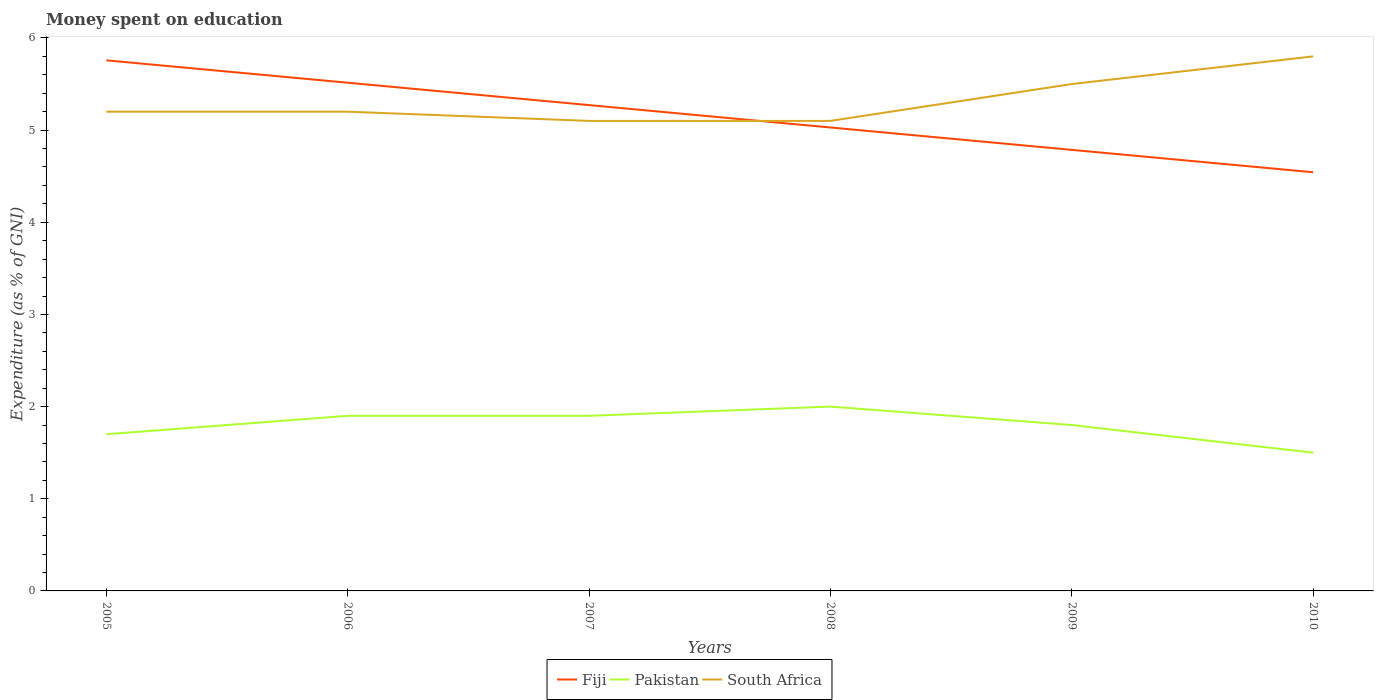Does the line corresponding to Pakistan intersect with the line corresponding to South Africa?
Your answer should be very brief. No. Is the number of lines equal to the number of legend labels?
Your response must be concise. Yes. What is the total amount of money spent on education in Pakistan in the graph?
Ensure brevity in your answer.  -0.2. What is the difference between the highest and the second highest amount of money spent on education in Pakistan?
Offer a terse response. 0.5. Is the amount of money spent on education in South Africa strictly greater than the amount of money spent on education in Pakistan over the years?
Offer a terse response. No. How many years are there in the graph?
Provide a short and direct response. 6. Are the values on the major ticks of Y-axis written in scientific E-notation?
Ensure brevity in your answer.  No. Does the graph contain any zero values?
Your response must be concise. No. Does the graph contain grids?
Your response must be concise. No. Where does the legend appear in the graph?
Your answer should be compact. Bottom center. How many legend labels are there?
Ensure brevity in your answer.  3. How are the legend labels stacked?
Keep it short and to the point. Horizontal. What is the title of the graph?
Make the answer very short. Money spent on education. What is the label or title of the Y-axis?
Keep it short and to the point. Expenditure (as % of GNI). What is the Expenditure (as % of GNI) in Fiji in 2005?
Provide a short and direct response. 5.76. What is the Expenditure (as % of GNI) of Fiji in 2006?
Ensure brevity in your answer.  5.51. What is the Expenditure (as % of GNI) of Pakistan in 2006?
Keep it short and to the point. 1.9. What is the Expenditure (as % of GNI) in Fiji in 2007?
Keep it short and to the point. 5.27. What is the Expenditure (as % of GNI) in Pakistan in 2007?
Your response must be concise. 1.9. What is the Expenditure (as % of GNI) in Fiji in 2008?
Offer a very short reply. 5.03. What is the Expenditure (as % of GNI) of Fiji in 2009?
Make the answer very short. 4.79. What is the Expenditure (as % of GNI) in Pakistan in 2009?
Make the answer very short. 1.8. What is the Expenditure (as % of GNI) in South Africa in 2009?
Keep it short and to the point. 5.5. What is the Expenditure (as % of GNI) in Fiji in 2010?
Your answer should be very brief. 4.54. What is the Expenditure (as % of GNI) of Pakistan in 2010?
Provide a succinct answer. 1.5. What is the Expenditure (as % of GNI) in South Africa in 2010?
Ensure brevity in your answer.  5.8. Across all years, what is the maximum Expenditure (as % of GNI) in Fiji?
Provide a succinct answer. 5.76. Across all years, what is the maximum Expenditure (as % of GNI) of South Africa?
Provide a succinct answer. 5.8. Across all years, what is the minimum Expenditure (as % of GNI) in Fiji?
Ensure brevity in your answer.  4.54. What is the total Expenditure (as % of GNI) in Fiji in the graph?
Ensure brevity in your answer.  30.9. What is the total Expenditure (as % of GNI) of South Africa in the graph?
Your response must be concise. 31.9. What is the difference between the Expenditure (as % of GNI) of Fiji in 2005 and that in 2006?
Your response must be concise. 0.24. What is the difference between the Expenditure (as % of GNI) in Pakistan in 2005 and that in 2006?
Make the answer very short. -0.2. What is the difference between the Expenditure (as % of GNI) in Fiji in 2005 and that in 2007?
Your answer should be compact. 0.49. What is the difference between the Expenditure (as % of GNI) in Fiji in 2005 and that in 2008?
Offer a very short reply. 0.73. What is the difference between the Expenditure (as % of GNI) of South Africa in 2005 and that in 2008?
Your answer should be compact. 0.1. What is the difference between the Expenditure (as % of GNI) in Fiji in 2005 and that in 2009?
Offer a very short reply. 0.97. What is the difference between the Expenditure (as % of GNI) in Pakistan in 2005 and that in 2009?
Offer a terse response. -0.1. What is the difference between the Expenditure (as % of GNI) in South Africa in 2005 and that in 2009?
Provide a short and direct response. -0.3. What is the difference between the Expenditure (as % of GNI) in Fiji in 2005 and that in 2010?
Ensure brevity in your answer.  1.21. What is the difference between the Expenditure (as % of GNI) in Pakistan in 2005 and that in 2010?
Give a very brief answer. 0.2. What is the difference between the Expenditure (as % of GNI) of Fiji in 2006 and that in 2007?
Your answer should be compact. 0.24. What is the difference between the Expenditure (as % of GNI) in Fiji in 2006 and that in 2008?
Your answer should be compact. 0.49. What is the difference between the Expenditure (as % of GNI) of Pakistan in 2006 and that in 2008?
Provide a short and direct response. -0.1. What is the difference between the Expenditure (as % of GNI) in Fiji in 2006 and that in 2009?
Ensure brevity in your answer.  0.73. What is the difference between the Expenditure (as % of GNI) in Pakistan in 2006 and that in 2009?
Make the answer very short. 0.1. What is the difference between the Expenditure (as % of GNI) in Fiji in 2006 and that in 2010?
Offer a terse response. 0.97. What is the difference between the Expenditure (as % of GNI) of South Africa in 2006 and that in 2010?
Provide a succinct answer. -0.6. What is the difference between the Expenditure (as % of GNI) of Fiji in 2007 and that in 2008?
Your answer should be compact. 0.24. What is the difference between the Expenditure (as % of GNI) in Pakistan in 2007 and that in 2008?
Offer a very short reply. -0.1. What is the difference between the Expenditure (as % of GNI) of Fiji in 2007 and that in 2009?
Your answer should be very brief. 0.49. What is the difference between the Expenditure (as % of GNI) in Fiji in 2007 and that in 2010?
Make the answer very short. 0.73. What is the difference between the Expenditure (as % of GNI) of Pakistan in 2007 and that in 2010?
Make the answer very short. 0.4. What is the difference between the Expenditure (as % of GNI) of South Africa in 2007 and that in 2010?
Offer a very short reply. -0.7. What is the difference between the Expenditure (as % of GNI) of Fiji in 2008 and that in 2009?
Your answer should be compact. 0.24. What is the difference between the Expenditure (as % of GNI) in Pakistan in 2008 and that in 2009?
Your answer should be very brief. 0.2. What is the difference between the Expenditure (as % of GNI) of Fiji in 2008 and that in 2010?
Ensure brevity in your answer.  0.49. What is the difference between the Expenditure (as % of GNI) of Pakistan in 2008 and that in 2010?
Your answer should be very brief. 0.5. What is the difference between the Expenditure (as % of GNI) of South Africa in 2008 and that in 2010?
Give a very brief answer. -0.7. What is the difference between the Expenditure (as % of GNI) in Fiji in 2009 and that in 2010?
Offer a terse response. 0.24. What is the difference between the Expenditure (as % of GNI) in Pakistan in 2009 and that in 2010?
Provide a succinct answer. 0.3. What is the difference between the Expenditure (as % of GNI) of Fiji in 2005 and the Expenditure (as % of GNI) of Pakistan in 2006?
Keep it short and to the point. 3.86. What is the difference between the Expenditure (as % of GNI) of Fiji in 2005 and the Expenditure (as % of GNI) of South Africa in 2006?
Offer a very short reply. 0.56. What is the difference between the Expenditure (as % of GNI) of Pakistan in 2005 and the Expenditure (as % of GNI) of South Africa in 2006?
Provide a short and direct response. -3.5. What is the difference between the Expenditure (as % of GNI) of Fiji in 2005 and the Expenditure (as % of GNI) of Pakistan in 2007?
Make the answer very short. 3.86. What is the difference between the Expenditure (as % of GNI) of Fiji in 2005 and the Expenditure (as % of GNI) of South Africa in 2007?
Keep it short and to the point. 0.66. What is the difference between the Expenditure (as % of GNI) in Fiji in 2005 and the Expenditure (as % of GNI) in Pakistan in 2008?
Ensure brevity in your answer.  3.76. What is the difference between the Expenditure (as % of GNI) in Fiji in 2005 and the Expenditure (as % of GNI) in South Africa in 2008?
Make the answer very short. 0.66. What is the difference between the Expenditure (as % of GNI) in Pakistan in 2005 and the Expenditure (as % of GNI) in South Africa in 2008?
Your response must be concise. -3.4. What is the difference between the Expenditure (as % of GNI) in Fiji in 2005 and the Expenditure (as % of GNI) in Pakistan in 2009?
Your answer should be very brief. 3.96. What is the difference between the Expenditure (as % of GNI) in Fiji in 2005 and the Expenditure (as % of GNI) in South Africa in 2009?
Offer a terse response. 0.26. What is the difference between the Expenditure (as % of GNI) in Fiji in 2005 and the Expenditure (as % of GNI) in Pakistan in 2010?
Offer a terse response. 4.26. What is the difference between the Expenditure (as % of GNI) in Fiji in 2005 and the Expenditure (as % of GNI) in South Africa in 2010?
Give a very brief answer. -0.04. What is the difference between the Expenditure (as % of GNI) of Pakistan in 2005 and the Expenditure (as % of GNI) of South Africa in 2010?
Your answer should be very brief. -4.1. What is the difference between the Expenditure (as % of GNI) of Fiji in 2006 and the Expenditure (as % of GNI) of Pakistan in 2007?
Offer a very short reply. 3.61. What is the difference between the Expenditure (as % of GNI) in Fiji in 2006 and the Expenditure (as % of GNI) in South Africa in 2007?
Keep it short and to the point. 0.41. What is the difference between the Expenditure (as % of GNI) of Fiji in 2006 and the Expenditure (as % of GNI) of Pakistan in 2008?
Provide a succinct answer. 3.51. What is the difference between the Expenditure (as % of GNI) of Fiji in 2006 and the Expenditure (as % of GNI) of South Africa in 2008?
Provide a succinct answer. 0.41. What is the difference between the Expenditure (as % of GNI) of Pakistan in 2006 and the Expenditure (as % of GNI) of South Africa in 2008?
Ensure brevity in your answer.  -3.2. What is the difference between the Expenditure (as % of GNI) in Fiji in 2006 and the Expenditure (as % of GNI) in Pakistan in 2009?
Keep it short and to the point. 3.71. What is the difference between the Expenditure (as % of GNI) of Fiji in 2006 and the Expenditure (as % of GNI) of South Africa in 2009?
Offer a very short reply. 0.01. What is the difference between the Expenditure (as % of GNI) of Fiji in 2006 and the Expenditure (as % of GNI) of Pakistan in 2010?
Offer a very short reply. 4.01. What is the difference between the Expenditure (as % of GNI) of Fiji in 2006 and the Expenditure (as % of GNI) of South Africa in 2010?
Ensure brevity in your answer.  -0.29. What is the difference between the Expenditure (as % of GNI) in Pakistan in 2006 and the Expenditure (as % of GNI) in South Africa in 2010?
Ensure brevity in your answer.  -3.9. What is the difference between the Expenditure (as % of GNI) in Fiji in 2007 and the Expenditure (as % of GNI) in Pakistan in 2008?
Offer a terse response. 3.27. What is the difference between the Expenditure (as % of GNI) of Fiji in 2007 and the Expenditure (as % of GNI) of South Africa in 2008?
Provide a succinct answer. 0.17. What is the difference between the Expenditure (as % of GNI) of Pakistan in 2007 and the Expenditure (as % of GNI) of South Africa in 2008?
Offer a very short reply. -3.2. What is the difference between the Expenditure (as % of GNI) in Fiji in 2007 and the Expenditure (as % of GNI) in Pakistan in 2009?
Offer a terse response. 3.47. What is the difference between the Expenditure (as % of GNI) of Fiji in 2007 and the Expenditure (as % of GNI) of South Africa in 2009?
Provide a succinct answer. -0.23. What is the difference between the Expenditure (as % of GNI) of Fiji in 2007 and the Expenditure (as % of GNI) of Pakistan in 2010?
Offer a very short reply. 3.77. What is the difference between the Expenditure (as % of GNI) of Fiji in 2007 and the Expenditure (as % of GNI) of South Africa in 2010?
Keep it short and to the point. -0.53. What is the difference between the Expenditure (as % of GNI) of Pakistan in 2007 and the Expenditure (as % of GNI) of South Africa in 2010?
Offer a very short reply. -3.9. What is the difference between the Expenditure (as % of GNI) of Fiji in 2008 and the Expenditure (as % of GNI) of Pakistan in 2009?
Your answer should be compact. 3.23. What is the difference between the Expenditure (as % of GNI) in Fiji in 2008 and the Expenditure (as % of GNI) in South Africa in 2009?
Your answer should be very brief. -0.47. What is the difference between the Expenditure (as % of GNI) of Fiji in 2008 and the Expenditure (as % of GNI) of Pakistan in 2010?
Your response must be concise. 3.53. What is the difference between the Expenditure (as % of GNI) in Fiji in 2008 and the Expenditure (as % of GNI) in South Africa in 2010?
Give a very brief answer. -0.77. What is the difference between the Expenditure (as % of GNI) of Fiji in 2009 and the Expenditure (as % of GNI) of Pakistan in 2010?
Make the answer very short. 3.29. What is the difference between the Expenditure (as % of GNI) in Fiji in 2009 and the Expenditure (as % of GNI) in South Africa in 2010?
Your answer should be very brief. -1.01. What is the average Expenditure (as % of GNI) of Fiji per year?
Offer a very short reply. 5.15. What is the average Expenditure (as % of GNI) in Pakistan per year?
Provide a succinct answer. 1.8. What is the average Expenditure (as % of GNI) of South Africa per year?
Provide a succinct answer. 5.32. In the year 2005, what is the difference between the Expenditure (as % of GNI) of Fiji and Expenditure (as % of GNI) of Pakistan?
Offer a terse response. 4.06. In the year 2005, what is the difference between the Expenditure (as % of GNI) in Fiji and Expenditure (as % of GNI) in South Africa?
Offer a terse response. 0.56. In the year 2005, what is the difference between the Expenditure (as % of GNI) in Pakistan and Expenditure (as % of GNI) in South Africa?
Give a very brief answer. -3.5. In the year 2006, what is the difference between the Expenditure (as % of GNI) in Fiji and Expenditure (as % of GNI) in Pakistan?
Offer a terse response. 3.61. In the year 2006, what is the difference between the Expenditure (as % of GNI) of Fiji and Expenditure (as % of GNI) of South Africa?
Provide a short and direct response. 0.31. In the year 2006, what is the difference between the Expenditure (as % of GNI) of Pakistan and Expenditure (as % of GNI) of South Africa?
Your answer should be very brief. -3.3. In the year 2007, what is the difference between the Expenditure (as % of GNI) of Fiji and Expenditure (as % of GNI) of Pakistan?
Your answer should be very brief. 3.37. In the year 2007, what is the difference between the Expenditure (as % of GNI) in Fiji and Expenditure (as % of GNI) in South Africa?
Provide a short and direct response. 0.17. In the year 2008, what is the difference between the Expenditure (as % of GNI) of Fiji and Expenditure (as % of GNI) of Pakistan?
Make the answer very short. 3.03. In the year 2008, what is the difference between the Expenditure (as % of GNI) of Fiji and Expenditure (as % of GNI) of South Africa?
Your response must be concise. -0.07. In the year 2009, what is the difference between the Expenditure (as % of GNI) in Fiji and Expenditure (as % of GNI) in Pakistan?
Your response must be concise. 2.99. In the year 2009, what is the difference between the Expenditure (as % of GNI) of Fiji and Expenditure (as % of GNI) of South Africa?
Offer a very short reply. -0.71. In the year 2009, what is the difference between the Expenditure (as % of GNI) of Pakistan and Expenditure (as % of GNI) of South Africa?
Offer a terse response. -3.7. In the year 2010, what is the difference between the Expenditure (as % of GNI) in Fiji and Expenditure (as % of GNI) in Pakistan?
Your response must be concise. 3.04. In the year 2010, what is the difference between the Expenditure (as % of GNI) of Fiji and Expenditure (as % of GNI) of South Africa?
Give a very brief answer. -1.26. What is the ratio of the Expenditure (as % of GNI) in Fiji in 2005 to that in 2006?
Give a very brief answer. 1.04. What is the ratio of the Expenditure (as % of GNI) in Pakistan in 2005 to that in 2006?
Ensure brevity in your answer.  0.89. What is the ratio of the Expenditure (as % of GNI) of South Africa in 2005 to that in 2006?
Give a very brief answer. 1. What is the ratio of the Expenditure (as % of GNI) of Fiji in 2005 to that in 2007?
Offer a very short reply. 1.09. What is the ratio of the Expenditure (as % of GNI) of Pakistan in 2005 to that in 2007?
Your answer should be very brief. 0.89. What is the ratio of the Expenditure (as % of GNI) in South Africa in 2005 to that in 2007?
Provide a short and direct response. 1.02. What is the ratio of the Expenditure (as % of GNI) in Fiji in 2005 to that in 2008?
Make the answer very short. 1.14. What is the ratio of the Expenditure (as % of GNI) in Pakistan in 2005 to that in 2008?
Provide a short and direct response. 0.85. What is the ratio of the Expenditure (as % of GNI) in South Africa in 2005 to that in 2008?
Give a very brief answer. 1.02. What is the ratio of the Expenditure (as % of GNI) in Fiji in 2005 to that in 2009?
Offer a very short reply. 1.2. What is the ratio of the Expenditure (as % of GNI) of Pakistan in 2005 to that in 2009?
Give a very brief answer. 0.94. What is the ratio of the Expenditure (as % of GNI) of South Africa in 2005 to that in 2009?
Provide a short and direct response. 0.95. What is the ratio of the Expenditure (as % of GNI) in Fiji in 2005 to that in 2010?
Your answer should be very brief. 1.27. What is the ratio of the Expenditure (as % of GNI) in Pakistan in 2005 to that in 2010?
Keep it short and to the point. 1.13. What is the ratio of the Expenditure (as % of GNI) in South Africa in 2005 to that in 2010?
Your answer should be very brief. 0.9. What is the ratio of the Expenditure (as % of GNI) of Fiji in 2006 to that in 2007?
Your answer should be very brief. 1.05. What is the ratio of the Expenditure (as % of GNI) in South Africa in 2006 to that in 2007?
Offer a very short reply. 1.02. What is the ratio of the Expenditure (as % of GNI) in Fiji in 2006 to that in 2008?
Offer a terse response. 1.1. What is the ratio of the Expenditure (as % of GNI) in Pakistan in 2006 to that in 2008?
Give a very brief answer. 0.95. What is the ratio of the Expenditure (as % of GNI) in South Africa in 2006 to that in 2008?
Your answer should be compact. 1.02. What is the ratio of the Expenditure (as % of GNI) in Fiji in 2006 to that in 2009?
Provide a short and direct response. 1.15. What is the ratio of the Expenditure (as % of GNI) in Pakistan in 2006 to that in 2009?
Ensure brevity in your answer.  1.06. What is the ratio of the Expenditure (as % of GNI) in South Africa in 2006 to that in 2009?
Provide a short and direct response. 0.95. What is the ratio of the Expenditure (as % of GNI) of Fiji in 2006 to that in 2010?
Your answer should be compact. 1.21. What is the ratio of the Expenditure (as % of GNI) in Pakistan in 2006 to that in 2010?
Make the answer very short. 1.27. What is the ratio of the Expenditure (as % of GNI) in South Africa in 2006 to that in 2010?
Your answer should be compact. 0.9. What is the ratio of the Expenditure (as % of GNI) in Fiji in 2007 to that in 2008?
Your answer should be compact. 1.05. What is the ratio of the Expenditure (as % of GNI) in Pakistan in 2007 to that in 2008?
Ensure brevity in your answer.  0.95. What is the ratio of the Expenditure (as % of GNI) of South Africa in 2007 to that in 2008?
Provide a succinct answer. 1. What is the ratio of the Expenditure (as % of GNI) in Fiji in 2007 to that in 2009?
Provide a short and direct response. 1.1. What is the ratio of the Expenditure (as % of GNI) in Pakistan in 2007 to that in 2009?
Ensure brevity in your answer.  1.06. What is the ratio of the Expenditure (as % of GNI) in South Africa in 2007 to that in 2009?
Keep it short and to the point. 0.93. What is the ratio of the Expenditure (as % of GNI) of Fiji in 2007 to that in 2010?
Give a very brief answer. 1.16. What is the ratio of the Expenditure (as % of GNI) of Pakistan in 2007 to that in 2010?
Provide a short and direct response. 1.27. What is the ratio of the Expenditure (as % of GNI) of South Africa in 2007 to that in 2010?
Offer a very short reply. 0.88. What is the ratio of the Expenditure (as % of GNI) of Fiji in 2008 to that in 2009?
Ensure brevity in your answer.  1.05. What is the ratio of the Expenditure (as % of GNI) in South Africa in 2008 to that in 2009?
Ensure brevity in your answer.  0.93. What is the ratio of the Expenditure (as % of GNI) in Fiji in 2008 to that in 2010?
Your answer should be compact. 1.11. What is the ratio of the Expenditure (as % of GNI) in Pakistan in 2008 to that in 2010?
Your answer should be very brief. 1.33. What is the ratio of the Expenditure (as % of GNI) in South Africa in 2008 to that in 2010?
Offer a very short reply. 0.88. What is the ratio of the Expenditure (as % of GNI) of Fiji in 2009 to that in 2010?
Your answer should be very brief. 1.05. What is the ratio of the Expenditure (as % of GNI) in Pakistan in 2009 to that in 2010?
Offer a very short reply. 1.2. What is the ratio of the Expenditure (as % of GNI) in South Africa in 2009 to that in 2010?
Make the answer very short. 0.95. What is the difference between the highest and the second highest Expenditure (as % of GNI) in Fiji?
Your answer should be compact. 0.24. What is the difference between the highest and the second highest Expenditure (as % of GNI) in South Africa?
Your answer should be very brief. 0.3. What is the difference between the highest and the lowest Expenditure (as % of GNI) of Fiji?
Offer a terse response. 1.21. What is the difference between the highest and the lowest Expenditure (as % of GNI) of Pakistan?
Make the answer very short. 0.5. 